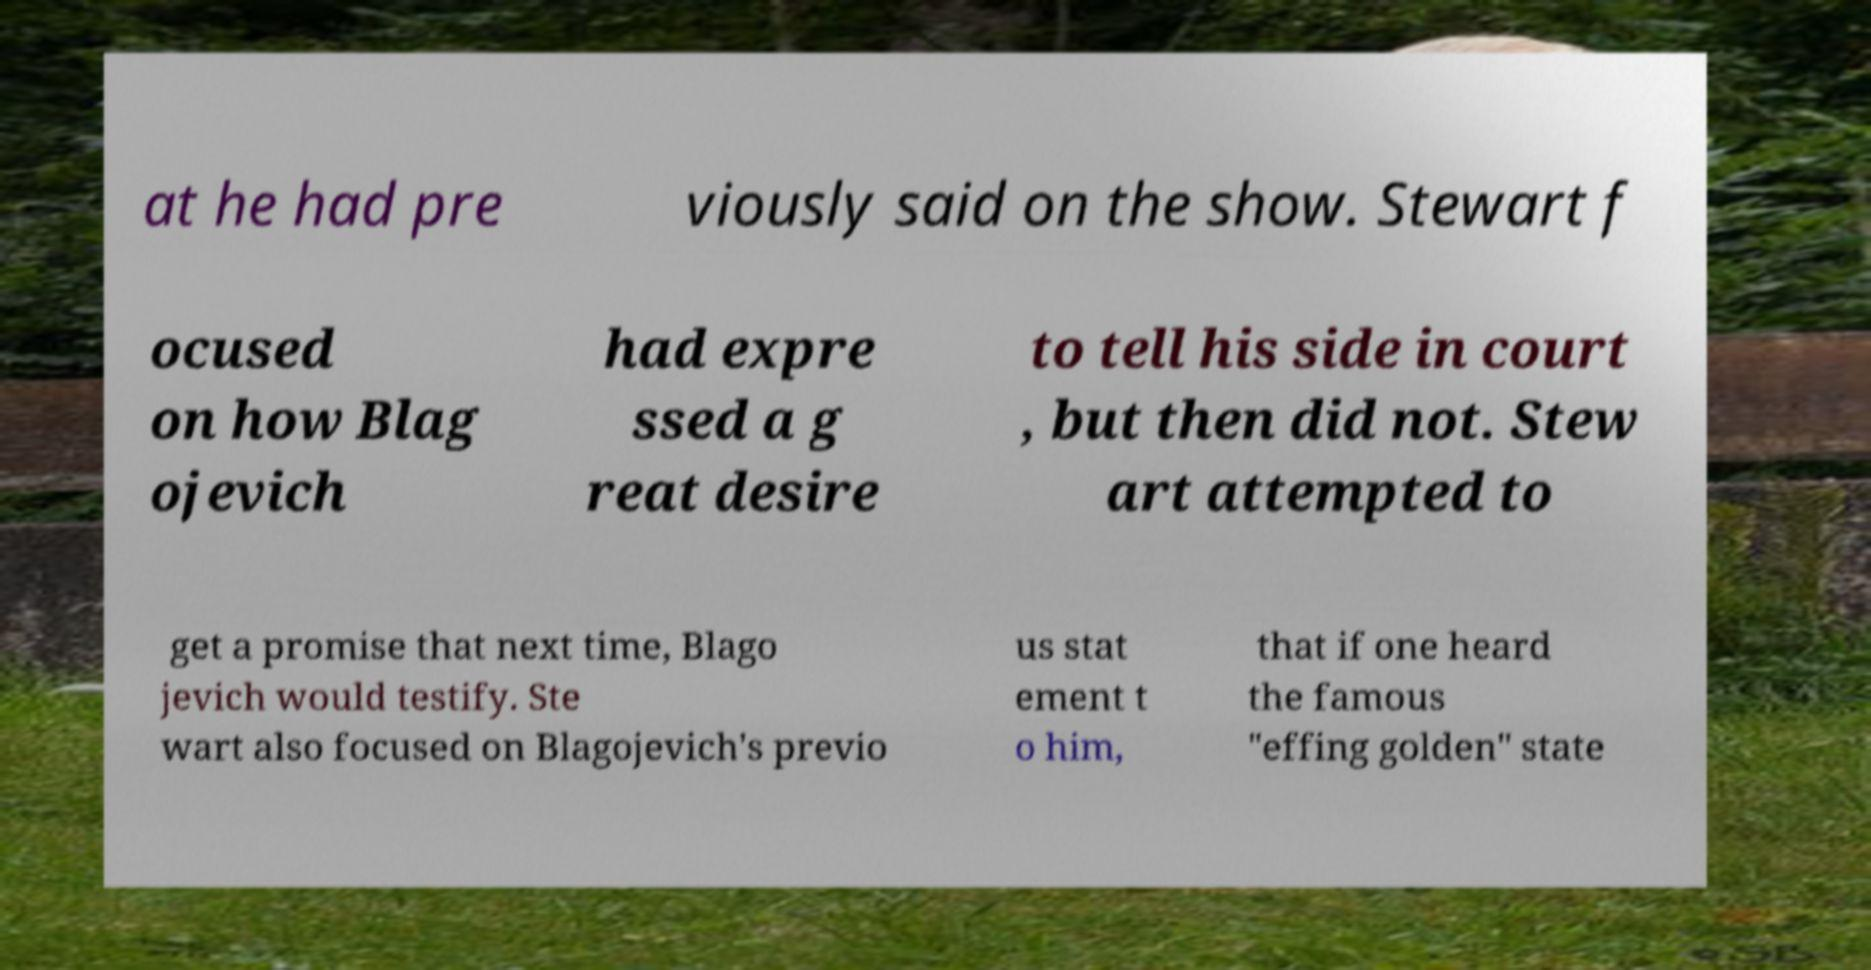Please identify and transcribe the text found in this image. at he had pre viously said on the show. Stewart f ocused on how Blag ojevich had expre ssed a g reat desire to tell his side in court , but then did not. Stew art attempted to get a promise that next time, Blago jevich would testify. Ste wart also focused on Blagojevich's previo us stat ement t o him, that if one heard the famous "effing golden" state 